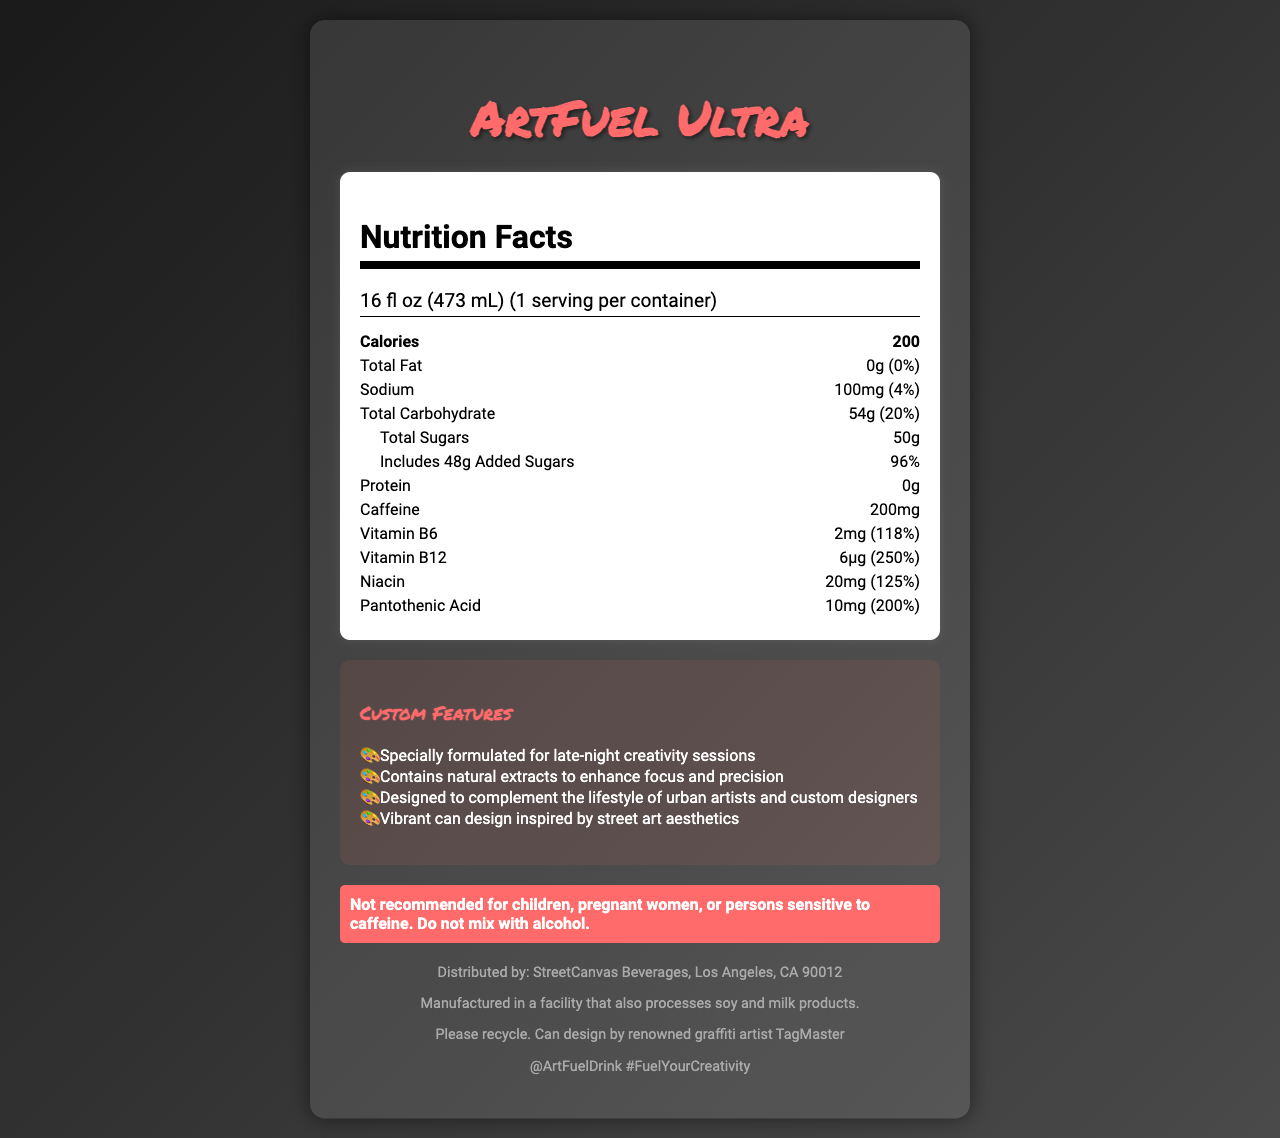what is the serving size of ArtFuel Ultra? The serving size is mentioned at the top of the Nutrition Facts section as "16 fl oz (473 mL)".
Answer: 16 fl oz (473 mL) how many calories are in one serving of ArtFuel Ultra? The calorie content is listed right below the serving size, indicating that one serving contains 200 calories.
Answer: 200 what is the total carbohydrate content? The total carbohydrate content is listed under the "Total Carbohydrate" section as 54g, with a daily value percentage of 20%.
Answer: 54g (20%) how much caffeine does ArtFuel Ultra contain? The caffeine content is listed under the "Caffeine" section as 200mg.
Answer: 200mg what is the daily value percentage of Vitamin B12 in ArtFuel Ultra? The daily value percentage for Vitamin B12 is listed as 250%.
Answer: 250% which nutrient has the highest daily value percentage?
A. Vitamin B6
B. Vitamin B12
C. Niacin
D. Protein The Vitamin B12 has a daily value percentage of 250%, higher than Vitamin B6 (118%), Niacin (125%), and Protein (0%).
Answer: B. Vitamin B12 which of the following ingredients is NOT listed in ArtFuel Ultra?
A. Carbonated Water
B. Panax Ginseng Root Extract
C. Ascorbic Acid
D. Maltodextrin Ascorbic Acid is not listed among the ingredients. The other ingredients: Carbonated Water, Panax Ginseng Root Extract, and Maltodextrin are listed.
Answer: C. Ascorbic Acid is ArtFuel Ultra recommended for children? The warning section states, "Not recommended for children, pregnant women, or persons sensitive to caffeine."
Answer: No summarize the main idea of the document. The document provides detailed nutritional information, highlights the custom features specifically designed for artists, and includes safety, recycling, and social media information.
Answer: ArtFuel Ultra is an energy drink designed for artists working long hours, with notable nutritional facts including 200 calories, high caffeine content, and vitamins B6, B12, Niacin, and Pantothenic Acid. The product also includes custom features for creative individuals, a vibrant can design, and a warning against use by children, pregnant women, or those sensitive to caffeine. what is the source of protein in ArtFuel Ultra? The document lists the protein content as 0g and does not specify any sources of protein.
Answer: Not enough information what is the allergen information for ArtFuel Ultra? The allergen information is provided at the bottom of the document under the distributor section.
Answer: Manufactured in a facility that also processes soy and milk products. 